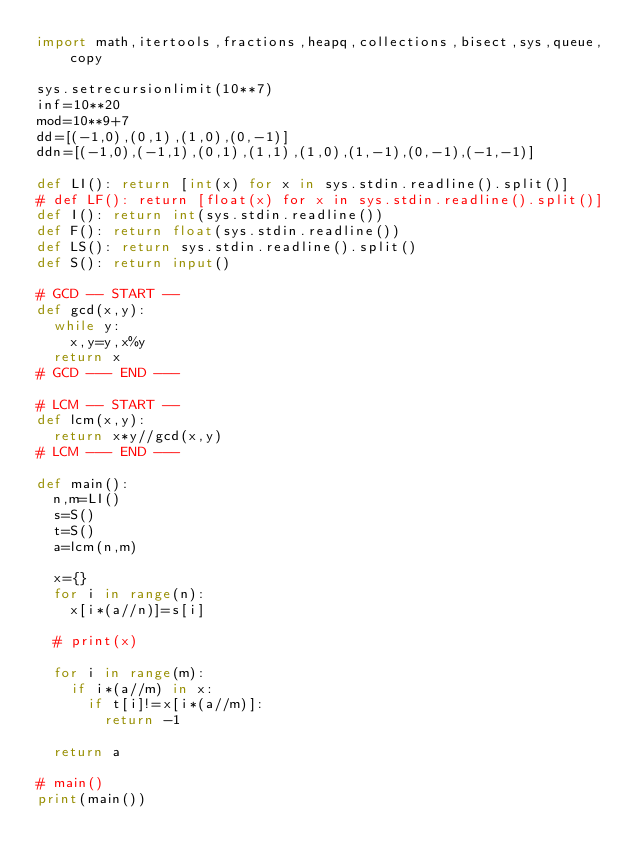<code> <loc_0><loc_0><loc_500><loc_500><_Python_>import math,itertools,fractions,heapq,collections,bisect,sys,queue,copy

sys.setrecursionlimit(10**7)
inf=10**20
mod=10**9+7
dd=[(-1,0),(0,1),(1,0),(0,-1)]
ddn=[(-1,0),(-1,1),(0,1),(1,1),(1,0),(1,-1),(0,-1),(-1,-1)]

def LI(): return [int(x) for x in sys.stdin.readline().split()]
# def LF(): return [float(x) for x in sys.stdin.readline().split()]
def I(): return int(sys.stdin.readline())
def F(): return float(sys.stdin.readline())
def LS(): return sys.stdin.readline().split()
def S(): return input()

# GCD -- START --
def gcd(x,y):
  while y:
    x,y=y,x%y
  return x
# GCD --- END ---

# LCM -- START --
def lcm(x,y):
  return x*y//gcd(x,y)
# LCM --- END ---

def main():
  n,m=LI()
  s=S()
  t=S()
  a=lcm(n,m)

  x={}
  for i in range(n):
    x[i*(a//n)]=s[i]

  # print(x)

  for i in range(m):
    if i*(a//m) in x:
      if t[i]!=x[i*(a//m)]:
        return -1

  return a

# main()
print(main())
</code> 